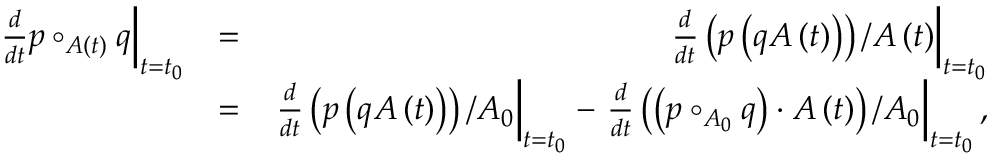Convert formula to latex. <formula><loc_0><loc_0><loc_500><loc_500>\begin{array} { r l r } { \frac { d } { d t } p \circ _ { A \left ( t \right ) } q \right | _ { t = t _ { 0 } } } & { = } & { \frac { d } { d t } \left ( p \left ( q A \left ( t \right ) \right ) \right ) / A \left ( t \right ) \right | _ { t = t _ { 0 } } } \\ & { = } & { \frac { d } { d t } \left ( p \left ( q A \left ( t \right ) \right ) \right ) / A _ { 0 } \right | _ { t = t _ { 0 } } - \frac { d } { d t } \left ( \left ( p \circ _ { A _ { 0 } } q \right ) \cdot A \left ( t \right ) \right ) / A _ { 0 } \right | _ { t = t _ { 0 } } , } \end{array}</formula> 